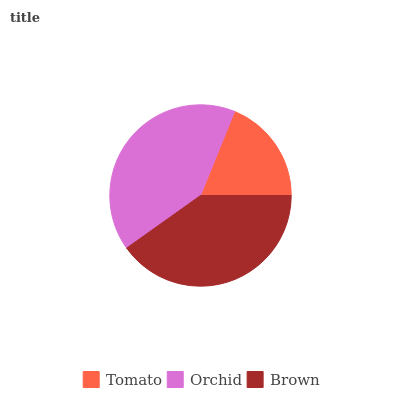Is Tomato the minimum?
Answer yes or no. Yes. Is Orchid the maximum?
Answer yes or no. Yes. Is Brown the minimum?
Answer yes or no. No. Is Brown the maximum?
Answer yes or no. No. Is Orchid greater than Brown?
Answer yes or no. Yes. Is Brown less than Orchid?
Answer yes or no. Yes. Is Brown greater than Orchid?
Answer yes or no. No. Is Orchid less than Brown?
Answer yes or no. No. Is Brown the high median?
Answer yes or no. Yes. Is Brown the low median?
Answer yes or no. Yes. Is Orchid the high median?
Answer yes or no. No. Is Orchid the low median?
Answer yes or no. No. 